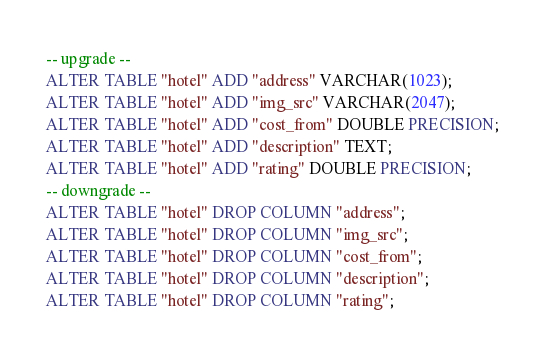<code> <loc_0><loc_0><loc_500><loc_500><_SQL_>-- upgrade --
ALTER TABLE "hotel" ADD "address" VARCHAR(1023);
ALTER TABLE "hotel" ADD "img_src" VARCHAR(2047);
ALTER TABLE "hotel" ADD "cost_from" DOUBLE PRECISION;
ALTER TABLE "hotel" ADD "description" TEXT;
ALTER TABLE "hotel" ADD "rating" DOUBLE PRECISION;
-- downgrade --
ALTER TABLE "hotel" DROP COLUMN "address";
ALTER TABLE "hotel" DROP COLUMN "img_src";
ALTER TABLE "hotel" DROP COLUMN "cost_from";
ALTER TABLE "hotel" DROP COLUMN "description";
ALTER TABLE "hotel" DROP COLUMN "rating";
</code> 